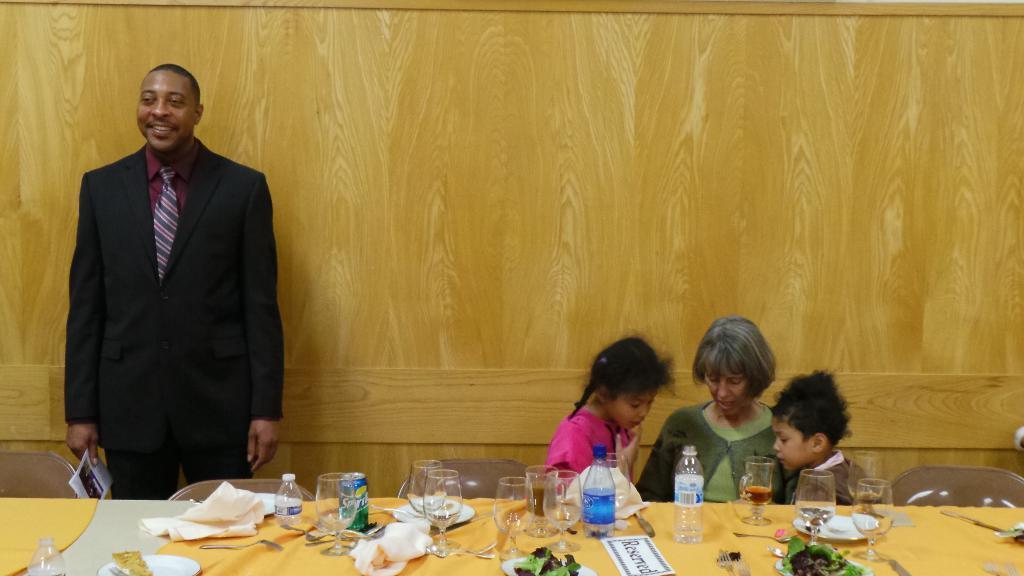Could you give a brief overview of what you see in this image? In this picture there is a guy standing to the left side and two kids and a woman are sitting on the table with food eatables on top of it. 